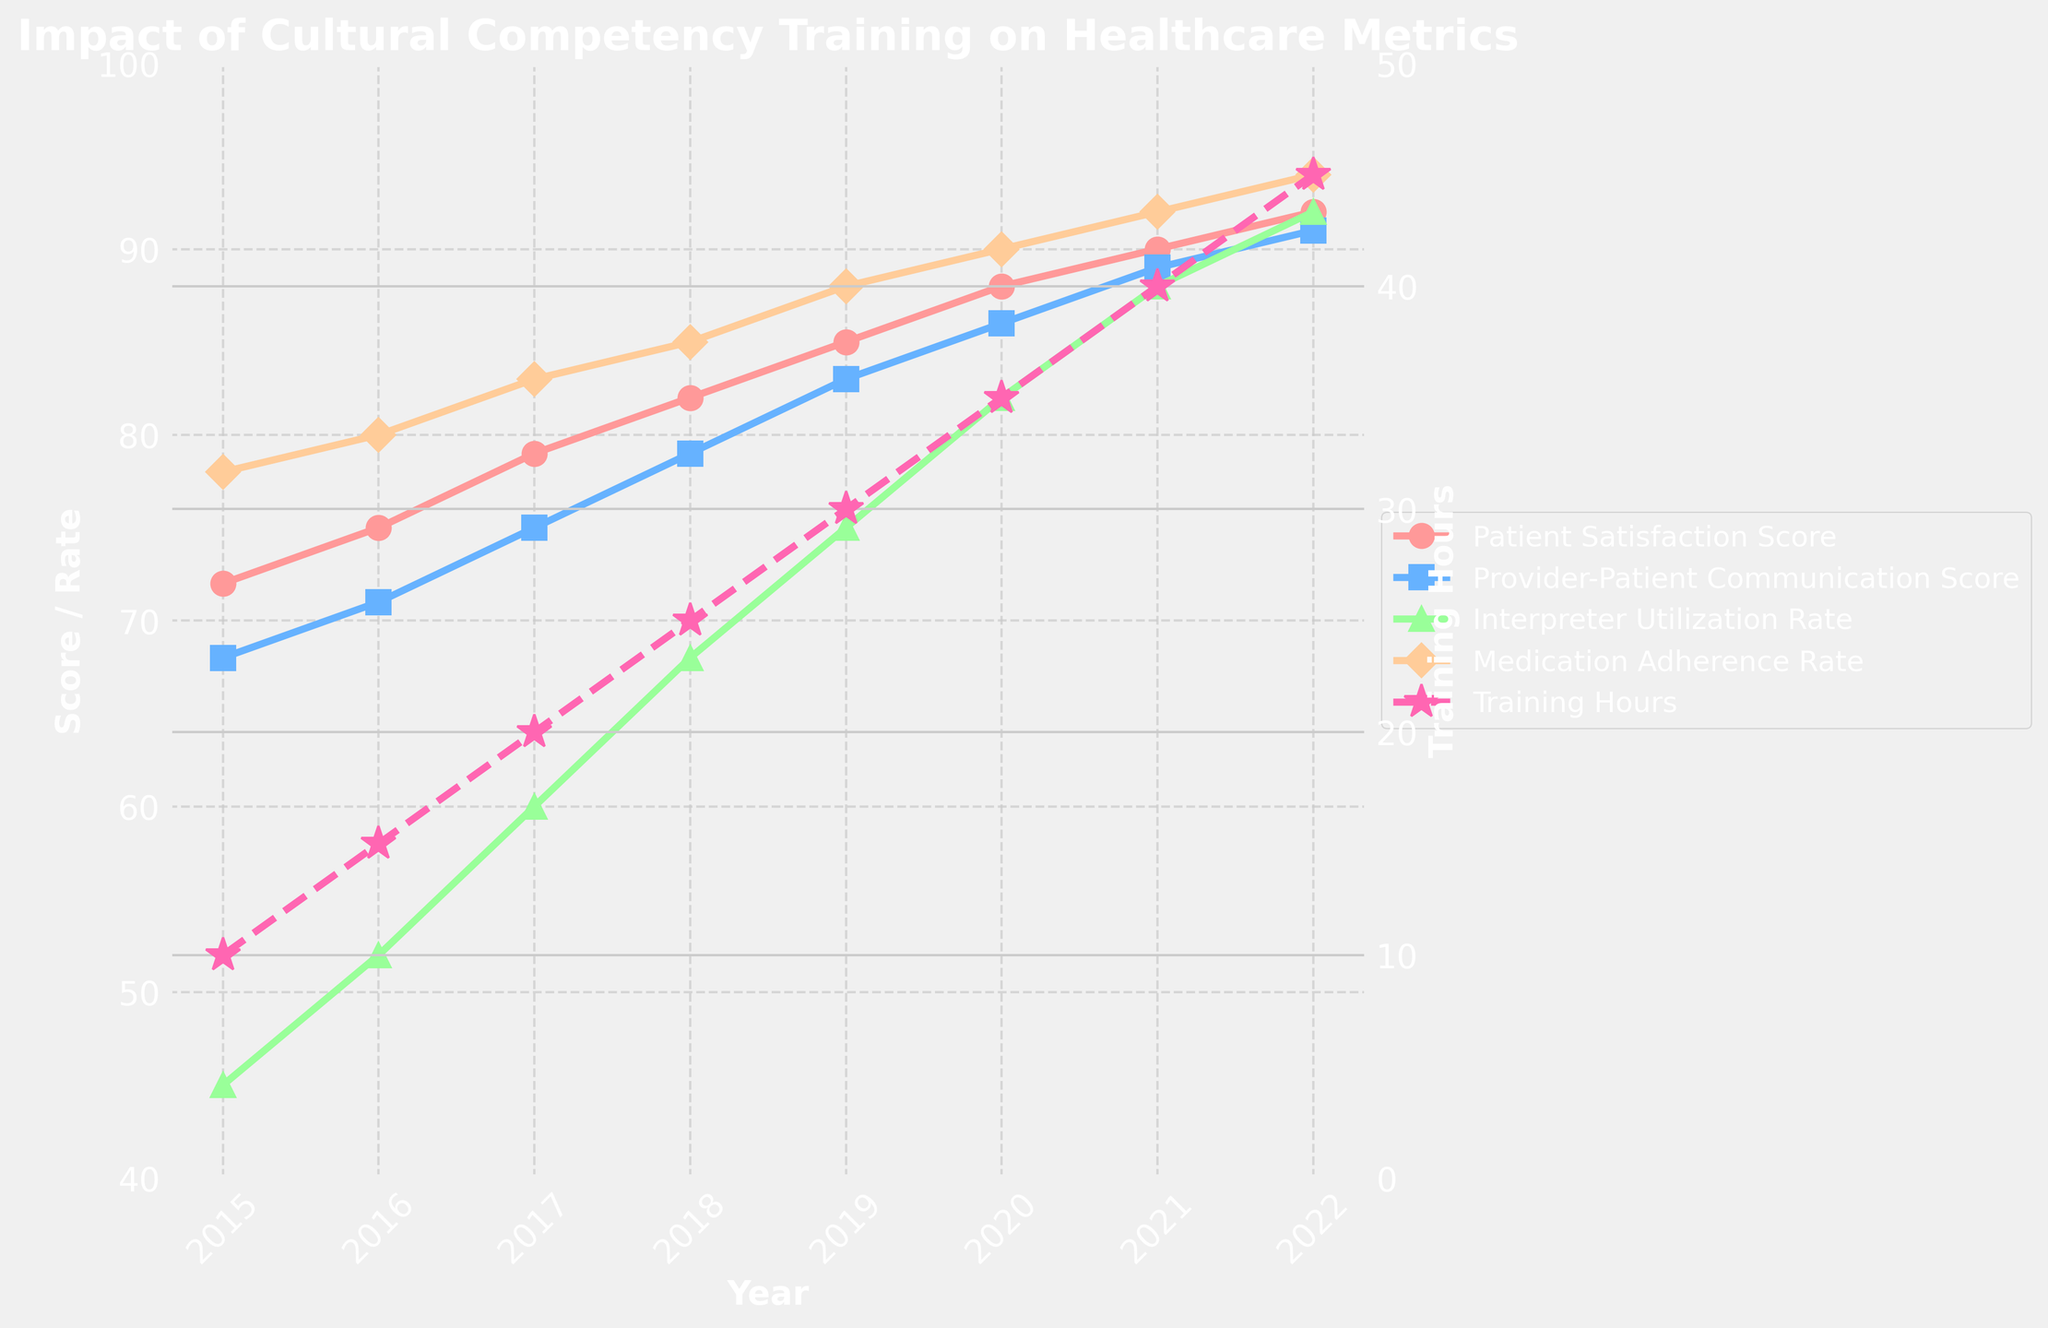What trend can be observed in the Provider-Patient Communication Score from 2015 to 2022? The Provider-Patient Communication Score shows a steady increase from 2015 to 2022. In 2015, the score was 68, and it gradually rose to 91 in 2022 with no drops in between the years. This suggests a consistent improvement in communication effectiveness over time.
Answer: Steady increase In which year was there the largest increase in Interpreter Utilization Rate compared to the previous year? To find the largest year-over-year increase in Interpreter Utilization Rate, we calculate the differences between consecutive years. The largest increase occurs from 2021 (88) to 2022 (92), which is an increase of 4 points.
Answer: 2022 How does the change in Cultural Competency Training Hours correlate with changes in Patient Satisfaction Score? To observe the correlation, note that as Cultural Competency Training Hours increase each year, the Patient Satisfaction Score also rises. There appears to be a positive correlation where increasing training hours results in higher patient satisfaction. For example, from 2015 to 2022, training hours increase from 10 to 45, and satisfaction score increases from 72 to 92.
Answer: Positive correlation What is the difference between the highest and lowest Medication Adherence Rate observed in the chart? The highest Medication Adherence Rate is in 2022, which is 94. The lowest is in 2015, which is 78. The difference is calculated as 94 - 78 = 16.
Answer: 16 Which metric shows the most significant improvement from 2015 to 2022? Looking at the initial and final values of each metric:
- Patient Satisfaction Score: 72 to 92 (improvement of 20)
- Provider-Patient Communication Score: 68 to 91 (improvement of 23)
- Interpreter Utilization Rate: 45 to 92 (improvement of 47)
- Medication Adherence Rate: 78 to 94 (improvement of 16)
The Interpreter Utilization Rate shows the most significant improvement.
Answer: Interpreter Utilization Rate How did the Patient Satisfaction Score in 2017 compare to that in 2020? In 2017, the Patient Satisfaction Score is 79. In 2020, it is 88. The score increased by 9 points from 2017 to 2020.
Answer: Increased by 9 points What color line represents the Medication Adherence Rate in the chart? The Medication Adherence Rate is represented by a peach-colored line. This can be identified by matching the color of the lines to the items in the legend on the right side of the chart.
Answer: Peach Between 2015 and 2019, which metric had the smallest overall increase? From 2015 to 2019, calculate the overall increase for each metric:
- Patient Satisfaction Score: 85 - 72 = 13
- Provider-Patient Communication Score: 83 - 68 = 15
- Interpreter Utilization Rate: 75 - 45 = 30
- Medication Adherence Rate: 88 - 78 = 10
The Medication Adherence Rate had the smallest overall increase of 10 points.
Answer: Medication Adherence Rate 